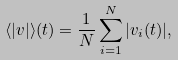<formula> <loc_0><loc_0><loc_500><loc_500>\langle | v | \rangle ( t ) = \frac { 1 } { N } \sum _ { i = 1 } ^ { N } | v _ { i } ( t ) | ,</formula> 